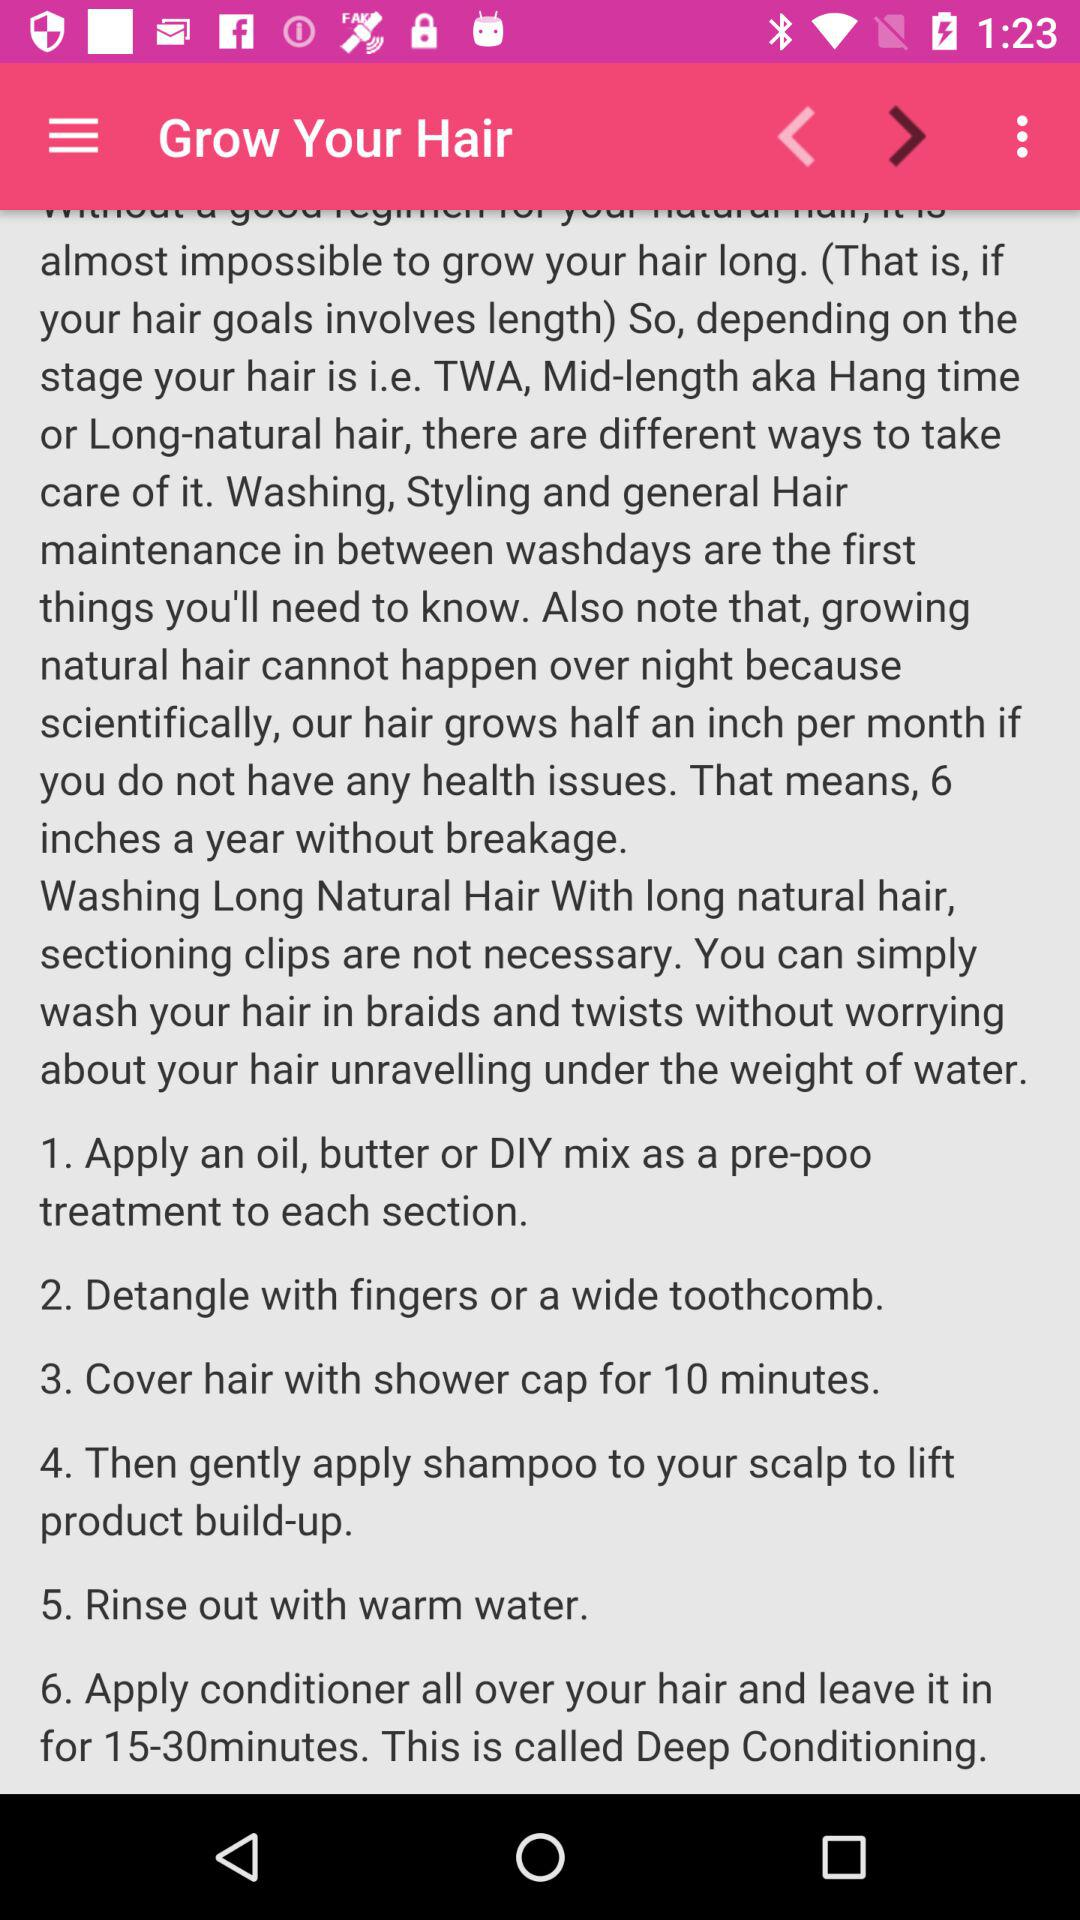How many steps are there in the process of washing long natural hair?
Answer the question using a single word or phrase. 6 